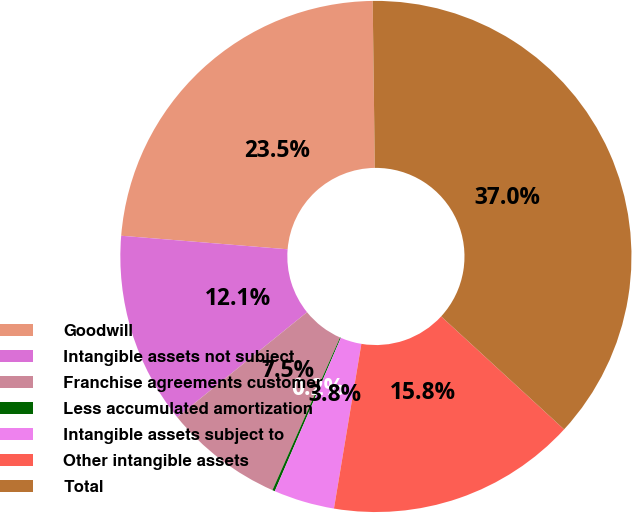Convert chart. <chart><loc_0><loc_0><loc_500><loc_500><pie_chart><fcel>Goodwill<fcel>Intangible assets not subject<fcel>Franchise agreements customer<fcel>Less accumulated amortization<fcel>Intangible assets subject to<fcel>Other intangible assets<fcel>Total<nl><fcel>23.51%<fcel>12.12%<fcel>7.54%<fcel>0.16%<fcel>3.85%<fcel>15.8%<fcel>37.03%<nl></chart> 